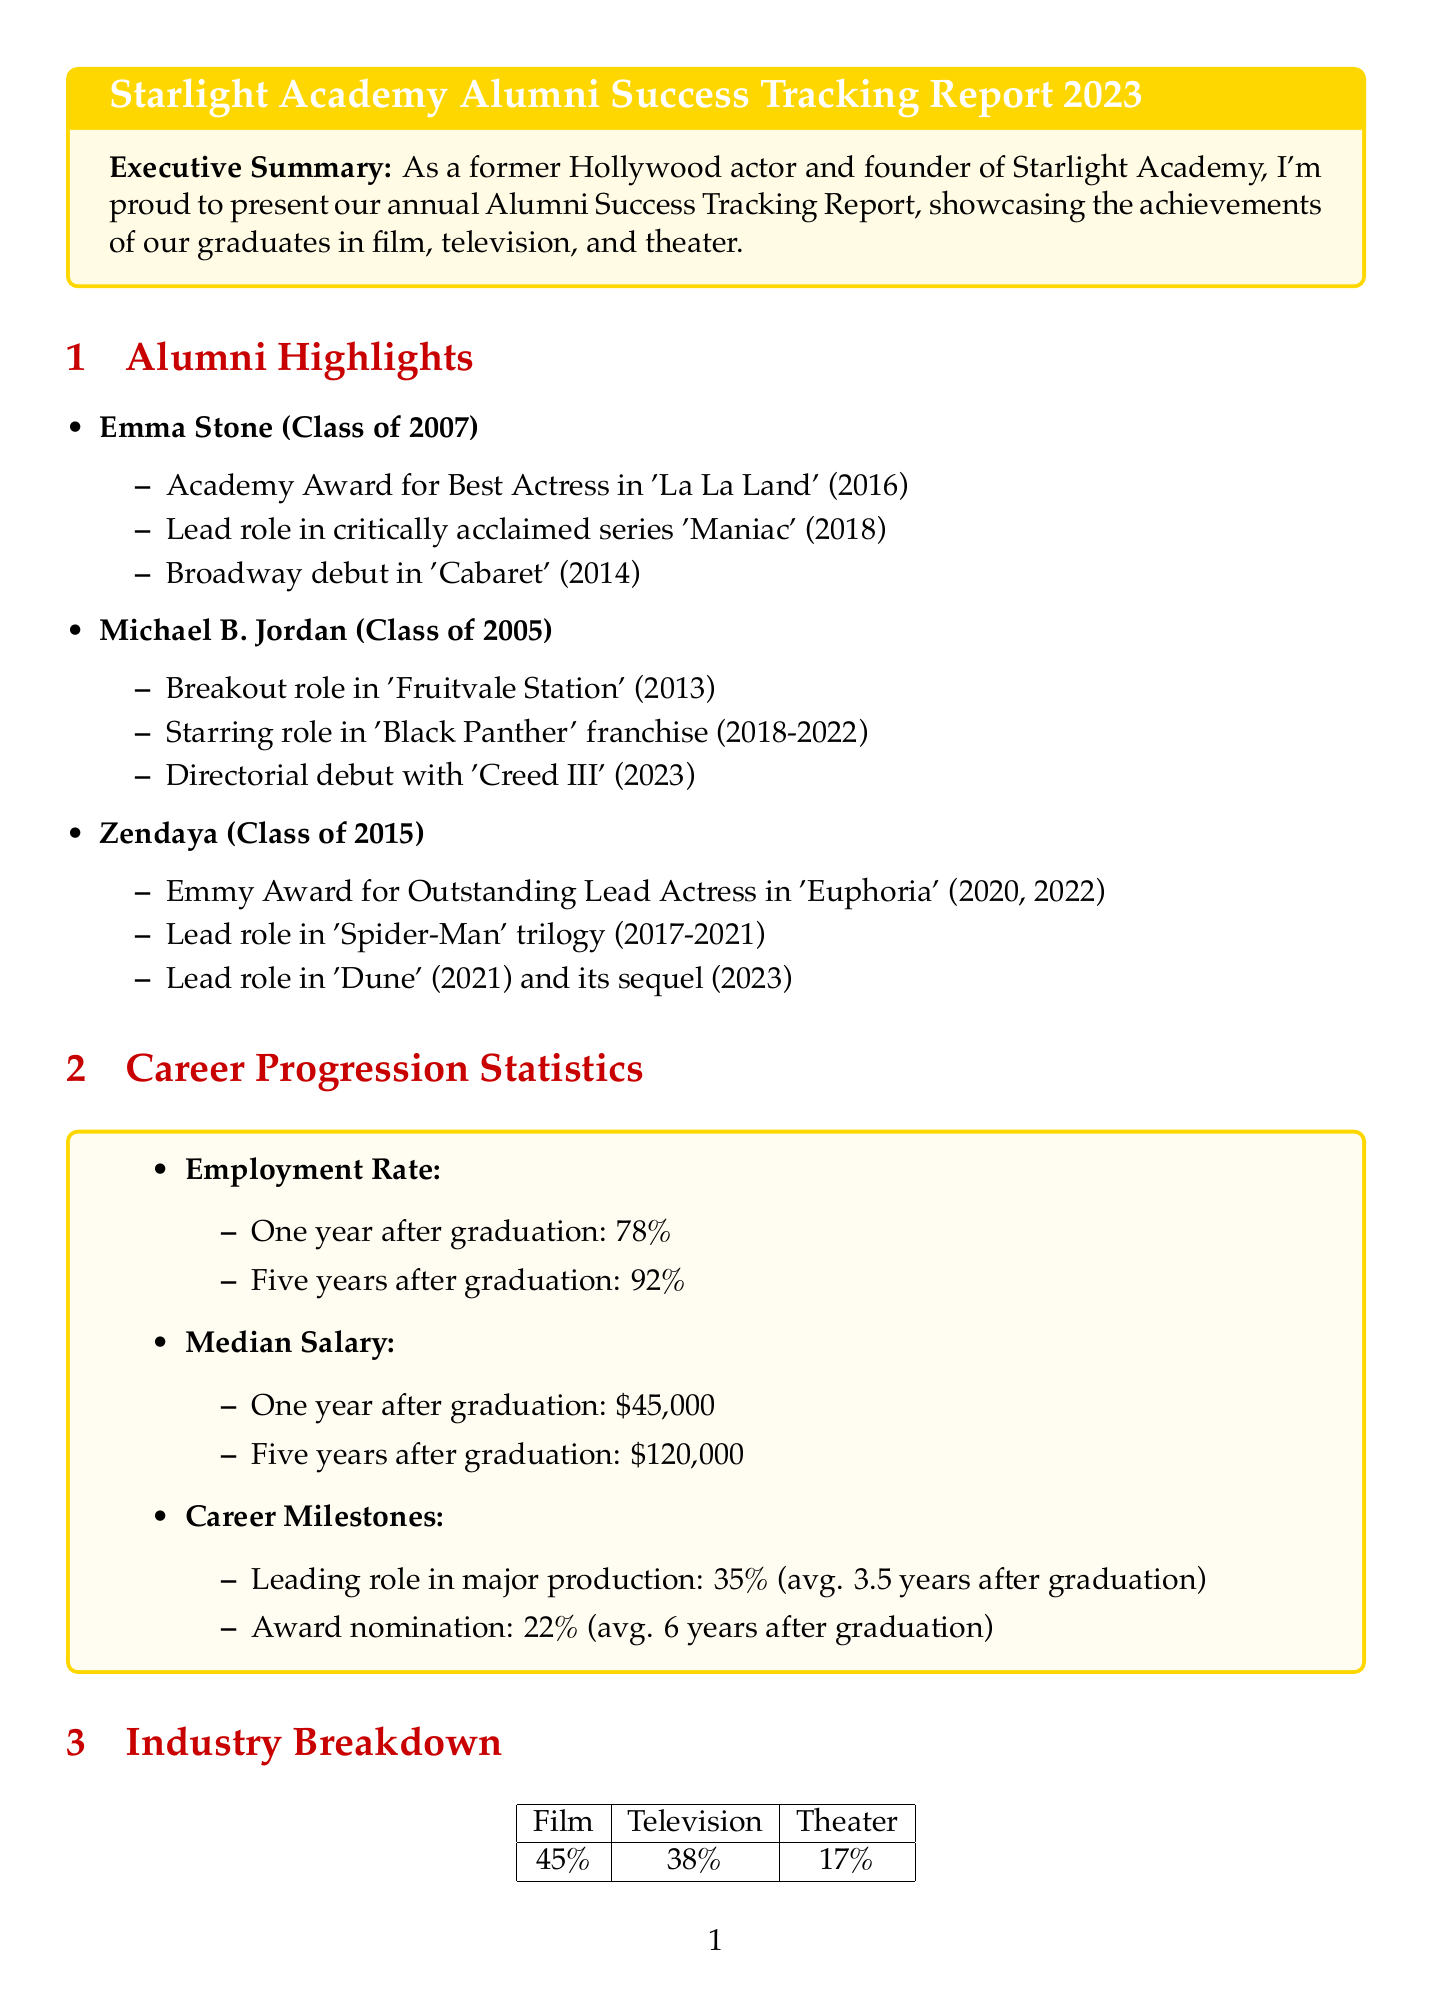What year did Emma Stone graduate? The graduation year of Emma Stone is specifically listed in the document as 2007.
Answer: 2007 What percentage of alumni achieved leading roles in major productions? The document states that 35% of alumni achieved leading roles in major productions.
Answer: 35% What is the median salary five years after graduation? The document provides that the median salary five years after graduation is $120,000.
Answer: $120,000 Which alumni won an Emmy Award for 'Euphoria'? The document names Zendaya as the alumni who won the Emmy Award for Outstanding Lead Actress in 'Euphoria'.
Answer: Zendaya How many notable productions are listed featuring alumni? The document lists a total of three notable productions featuring alumni, as seen in the notable productions section.
Answer: 3 What facilitated Tom Holland's success according to his testimonial? Tom Holland credits the mentorship and guidance he received at Starlight Academy for his success.
Answer: Mentorship and guidance What is the employment rate one year after graduation? The document outlines that the employment rate one year after graduation is 78%.
Answer: 78% What type of productions do 45% of alumni work in according to the industry breakdown? The industry breakdown specifies that 45% of alumni work in film.
Answer: Film What was the average timeframe for achieving an award nomination? The document indicates that the average timeframe for achieving an award nomination is 6 years after graduation.
Answer: 6 years 